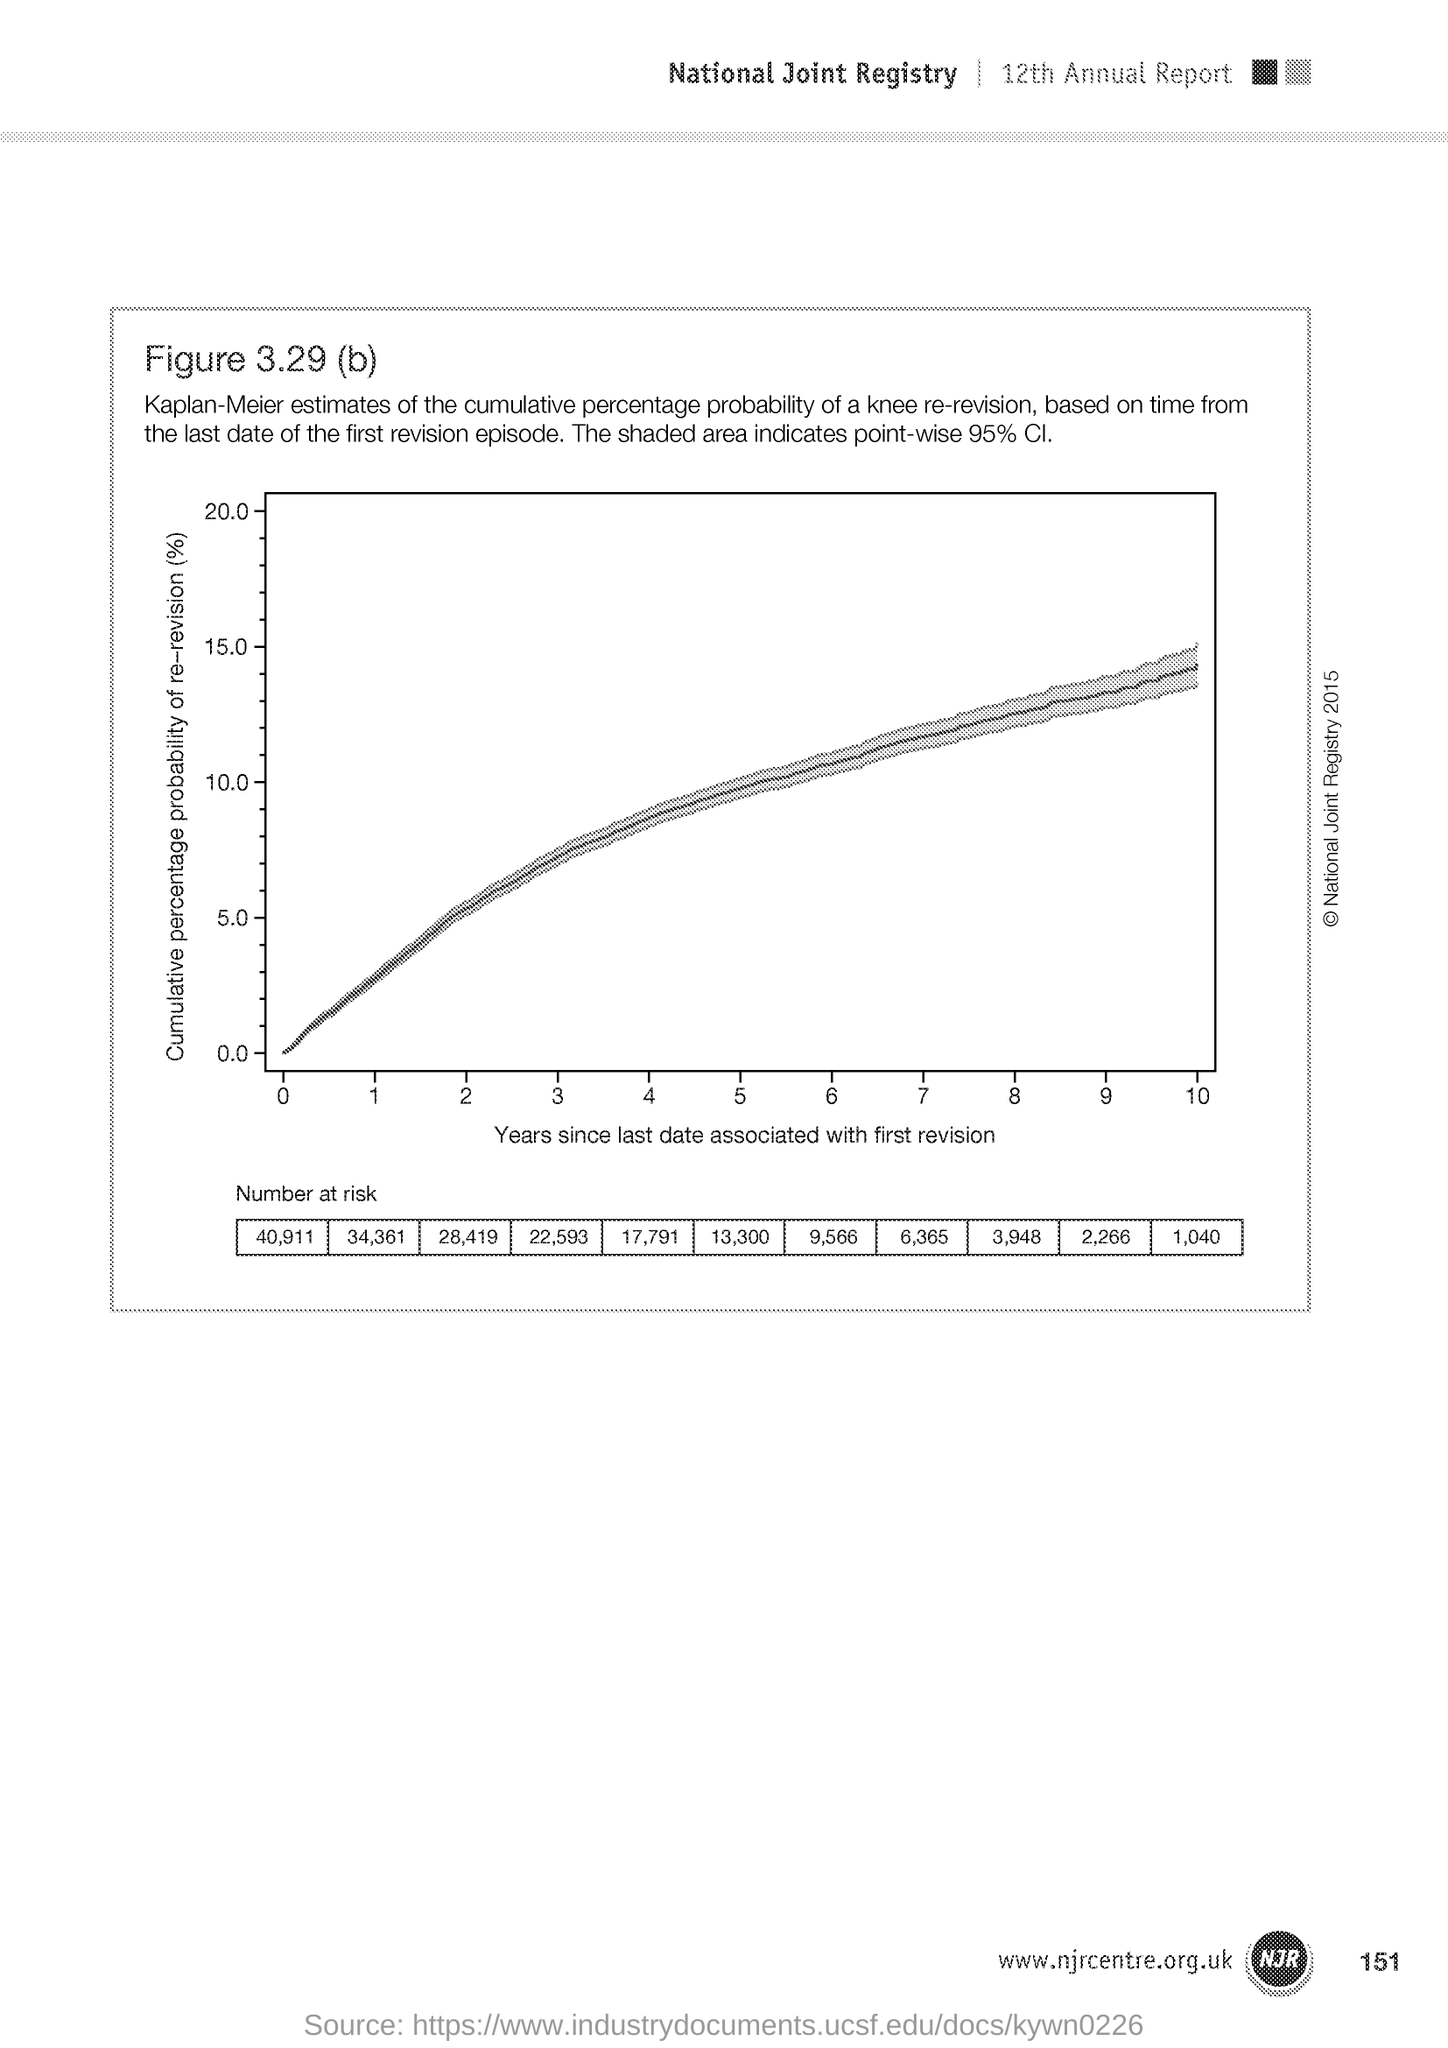Give some essential details in this illustration. The x-axis of the graph represents the number of years that have passed since the last date associated with the first revision. The y-axis of the graph represents the cumulative percentage probability of re-revision, which is the probability of being revised again given that the paper has already been revised at least once. The page number mentioned in this document is 151. 